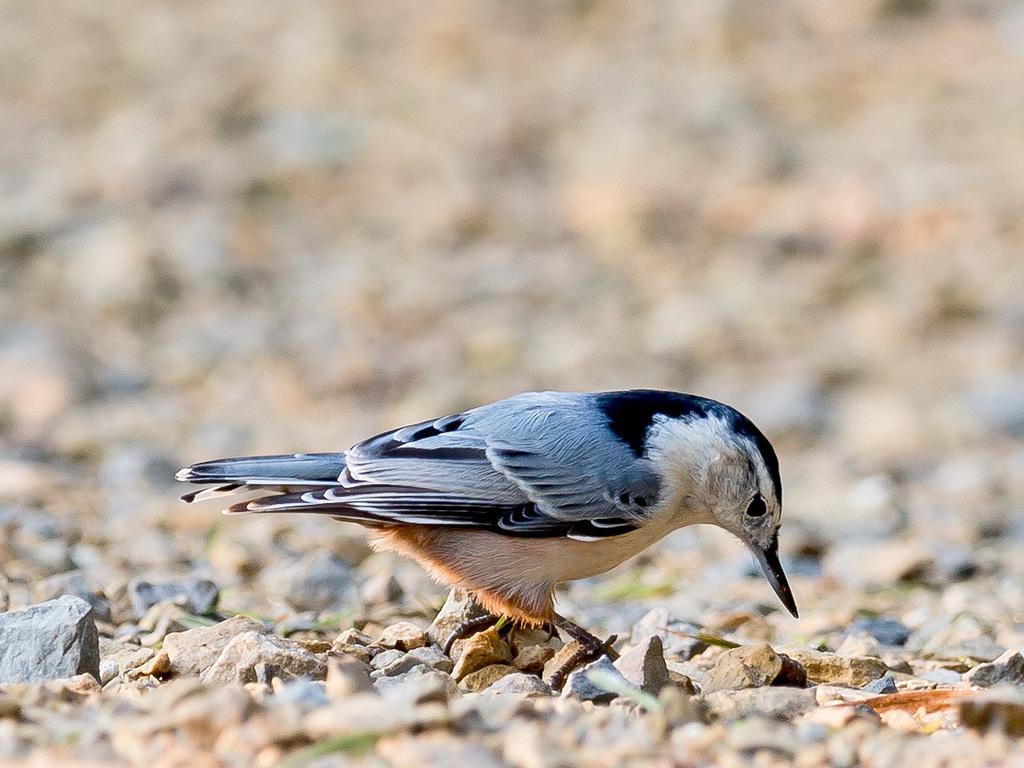Describe this image in one or two sentences. In the image there is a bird standing on the land with stones all over it. 